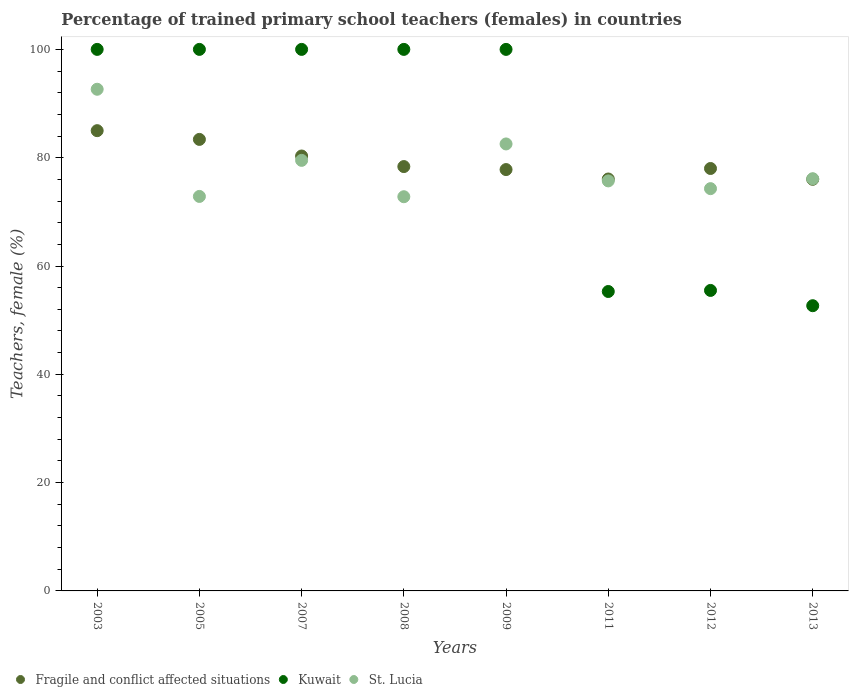What is the percentage of trained primary school teachers (females) in St. Lucia in 2007?
Your answer should be very brief. 79.51. Across all years, what is the maximum percentage of trained primary school teachers (females) in St. Lucia?
Make the answer very short. 92.64. Across all years, what is the minimum percentage of trained primary school teachers (females) in Kuwait?
Provide a succinct answer. 52.67. In which year was the percentage of trained primary school teachers (females) in Kuwait minimum?
Keep it short and to the point. 2013. What is the total percentage of trained primary school teachers (females) in Fragile and conflict affected situations in the graph?
Make the answer very short. 634.93. What is the difference between the percentage of trained primary school teachers (females) in Kuwait in 2007 and that in 2012?
Your answer should be compact. 44.51. What is the difference between the percentage of trained primary school teachers (females) in Kuwait in 2011 and the percentage of trained primary school teachers (females) in Fragile and conflict affected situations in 2009?
Your answer should be compact. -22.51. What is the average percentage of trained primary school teachers (females) in St. Lucia per year?
Offer a very short reply. 78.31. In the year 2005, what is the difference between the percentage of trained primary school teachers (females) in Fragile and conflict affected situations and percentage of trained primary school teachers (females) in Kuwait?
Make the answer very short. -16.62. Is the percentage of trained primary school teachers (females) in St. Lucia in 2003 less than that in 2011?
Ensure brevity in your answer.  No. Is the difference between the percentage of trained primary school teachers (females) in Fragile and conflict affected situations in 2007 and 2012 greater than the difference between the percentage of trained primary school teachers (females) in Kuwait in 2007 and 2012?
Ensure brevity in your answer.  No. What is the difference between the highest and the second highest percentage of trained primary school teachers (females) in St. Lucia?
Your answer should be very brief. 10.1. What is the difference between the highest and the lowest percentage of trained primary school teachers (females) in St. Lucia?
Make the answer very short. 19.84. In how many years, is the percentage of trained primary school teachers (females) in St. Lucia greater than the average percentage of trained primary school teachers (females) in St. Lucia taken over all years?
Your answer should be very brief. 3. Does the percentage of trained primary school teachers (females) in St. Lucia monotonically increase over the years?
Offer a very short reply. No. How many dotlines are there?
Provide a succinct answer. 3. How many years are there in the graph?
Keep it short and to the point. 8. Does the graph contain grids?
Ensure brevity in your answer.  No. How many legend labels are there?
Your answer should be very brief. 3. How are the legend labels stacked?
Your response must be concise. Horizontal. What is the title of the graph?
Provide a short and direct response. Percentage of trained primary school teachers (females) in countries. What is the label or title of the X-axis?
Your answer should be very brief. Years. What is the label or title of the Y-axis?
Your response must be concise. Teachers, female (%). What is the Teachers, female (%) in Fragile and conflict affected situations in 2003?
Give a very brief answer. 84.99. What is the Teachers, female (%) of Kuwait in 2003?
Provide a short and direct response. 100. What is the Teachers, female (%) in St. Lucia in 2003?
Make the answer very short. 92.64. What is the Teachers, female (%) of Fragile and conflict affected situations in 2005?
Offer a very short reply. 83.38. What is the Teachers, female (%) in Kuwait in 2005?
Your answer should be compact. 100. What is the Teachers, female (%) of St. Lucia in 2005?
Provide a succinct answer. 72.85. What is the Teachers, female (%) in Fragile and conflict affected situations in 2007?
Give a very brief answer. 80.31. What is the Teachers, female (%) of Kuwait in 2007?
Keep it short and to the point. 100. What is the Teachers, female (%) in St. Lucia in 2007?
Ensure brevity in your answer.  79.51. What is the Teachers, female (%) of Fragile and conflict affected situations in 2008?
Your response must be concise. 78.36. What is the Teachers, female (%) of St. Lucia in 2008?
Your response must be concise. 72.79. What is the Teachers, female (%) of Fragile and conflict affected situations in 2009?
Keep it short and to the point. 77.81. What is the Teachers, female (%) of St. Lucia in 2009?
Give a very brief answer. 82.54. What is the Teachers, female (%) of Fragile and conflict affected situations in 2011?
Your answer should be compact. 76.07. What is the Teachers, female (%) of Kuwait in 2011?
Give a very brief answer. 55.29. What is the Teachers, female (%) of St. Lucia in 2011?
Your answer should be very brief. 75.71. What is the Teachers, female (%) in Fragile and conflict affected situations in 2012?
Give a very brief answer. 78.01. What is the Teachers, female (%) of Kuwait in 2012?
Make the answer very short. 55.49. What is the Teachers, female (%) of St. Lucia in 2012?
Keep it short and to the point. 74.29. What is the Teachers, female (%) in Fragile and conflict affected situations in 2013?
Your answer should be compact. 76.01. What is the Teachers, female (%) of Kuwait in 2013?
Your answer should be compact. 52.67. What is the Teachers, female (%) of St. Lucia in 2013?
Offer a terse response. 76.12. Across all years, what is the maximum Teachers, female (%) of Fragile and conflict affected situations?
Your answer should be compact. 84.99. Across all years, what is the maximum Teachers, female (%) in Kuwait?
Provide a short and direct response. 100. Across all years, what is the maximum Teachers, female (%) in St. Lucia?
Make the answer very short. 92.64. Across all years, what is the minimum Teachers, female (%) in Fragile and conflict affected situations?
Give a very brief answer. 76.01. Across all years, what is the minimum Teachers, female (%) of Kuwait?
Your response must be concise. 52.67. Across all years, what is the minimum Teachers, female (%) in St. Lucia?
Your answer should be very brief. 72.79. What is the total Teachers, female (%) of Fragile and conflict affected situations in the graph?
Your response must be concise. 634.93. What is the total Teachers, female (%) of Kuwait in the graph?
Your response must be concise. 663.45. What is the total Teachers, female (%) of St. Lucia in the graph?
Ensure brevity in your answer.  626.45. What is the difference between the Teachers, female (%) in Fragile and conflict affected situations in 2003 and that in 2005?
Give a very brief answer. 1.61. What is the difference between the Teachers, female (%) of Kuwait in 2003 and that in 2005?
Offer a terse response. 0. What is the difference between the Teachers, female (%) in St. Lucia in 2003 and that in 2005?
Your response must be concise. 19.79. What is the difference between the Teachers, female (%) in Fragile and conflict affected situations in 2003 and that in 2007?
Your response must be concise. 4.68. What is the difference between the Teachers, female (%) of St. Lucia in 2003 and that in 2007?
Your answer should be very brief. 13.13. What is the difference between the Teachers, female (%) of Fragile and conflict affected situations in 2003 and that in 2008?
Give a very brief answer. 6.63. What is the difference between the Teachers, female (%) of St. Lucia in 2003 and that in 2008?
Provide a short and direct response. 19.84. What is the difference between the Teachers, female (%) of Fragile and conflict affected situations in 2003 and that in 2009?
Give a very brief answer. 7.18. What is the difference between the Teachers, female (%) in Kuwait in 2003 and that in 2009?
Ensure brevity in your answer.  0. What is the difference between the Teachers, female (%) in St. Lucia in 2003 and that in 2009?
Ensure brevity in your answer.  10.1. What is the difference between the Teachers, female (%) of Fragile and conflict affected situations in 2003 and that in 2011?
Ensure brevity in your answer.  8.93. What is the difference between the Teachers, female (%) of Kuwait in 2003 and that in 2011?
Your answer should be compact. 44.71. What is the difference between the Teachers, female (%) in St. Lucia in 2003 and that in 2011?
Offer a very short reply. 16.92. What is the difference between the Teachers, female (%) of Fragile and conflict affected situations in 2003 and that in 2012?
Keep it short and to the point. 6.99. What is the difference between the Teachers, female (%) of Kuwait in 2003 and that in 2012?
Offer a terse response. 44.51. What is the difference between the Teachers, female (%) of St. Lucia in 2003 and that in 2012?
Make the answer very short. 18.35. What is the difference between the Teachers, female (%) in Fragile and conflict affected situations in 2003 and that in 2013?
Your answer should be very brief. 8.98. What is the difference between the Teachers, female (%) in Kuwait in 2003 and that in 2013?
Offer a very short reply. 47.33. What is the difference between the Teachers, female (%) in St. Lucia in 2003 and that in 2013?
Provide a succinct answer. 16.52. What is the difference between the Teachers, female (%) in Fragile and conflict affected situations in 2005 and that in 2007?
Offer a very short reply. 3.07. What is the difference between the Teachers, female (%) in Kuwait in 2005 and that in 2007?
Offer a very short reply. 0. What is the difference between the Teachers, female (%) in St. Lucia in 2005 and that in 2007?
Your response must be concise. -6.66. What is the difference between the Teachers, female (%) in Fragile and conflict affected situations in 2005 and that in 2008?
Ensure brevity in your answer.  5.02. What is the difference between the Teachers, female (%) in Kuwait in 2005 and that in 2008?
Keep it short and to the point. 0. What is the difference between the Teachers, female (%) in St. Lucia in 2005 and that in 2008?
Your response must be concise. 0.05. What is the difference between the Teachers, female (%) of Fragile and conflict affected situations in 2005 and that in 2009?
Ensure brevity in your answer.  5.57. What is the difference between the Teachers, female (%) in Kuwait in 2005 and that in 2009?
Provide a succinct answer. 0. What is the difference between the Teachers, female (%) of St. Lucia in 2005 and that in 2009?
Provide a short and direct response. -9.69. What is the difference between the Teachers, female (%) in Fragile and conflict affected situations in 2005 and that in 2011?
Ensure brevity in your answer.  7.31. What is the difference between the Teachers, female (%) in Kuwait in 2005 and that in 2011?
Your answer should be compact. 44.71. What is the difference between the Teachers, female (%) of St. Lucia in 2005 and that in 2011?
Your answer should be very brief. -2.87. What is the difference between the Teachers, female (%) of Fragile and conflict affected situations in 2005 and that in 2012?
Provide a short and direct response. 5.37. What is the difference between the Teachers, female (%) in Kuwait in 2005 and that in 2012?
Offer a very short reply. 44.51. What is the difference between the Teachers, female (%) in St. Lucia in 2005 and that in 2012?
Ensure brevity in your answer.  -1.44. What is the difference between the Teachers, female (%) of Fragile and conflict affected situations in 2005 and that in 2013?
Offer a terse response. 7.37. What is the difference between the Teachers, female (%) in Kuwait in 2005 and that in 2013?
Make the answer very short. 47.33. What is the difference between the Teachers, female (%) of St. Lucia in 2005 and that in 2013?
Give a very brief answer. -3.27. What is the difference between the Teachers, female (%) in Fragile and conflict affected situations in 2007 and that in 2008?
Offer a terse response. 1.95. What is the difference between the Teachers, female (%) of St. Lucia in 2007 and that in 2008?
Your answer should be very brief. 6.71. What is the difference between the Teachers, female (%) in Fragile and conflict affected situations in 2007 and that in 2009?
Offer a very short reply. 2.5. What is the difference between the Teachers, female (%) in St. Lucia in 2007 and that in 2009?
Your answer should be compact. -3.03. What is the difference between the Teachers, female (%) of Fragile and conflict affected situations in 2007 and that in 2011?
Provide a short and direct response. 4.25. What is the difference between the Teachers, female (%) of Kuwait in 2007 and that in 2011?
Your response must be concise. 44.71. What is the difference between the Teachers, female (%) of St. Lucia in 2007 and that in 2011?
Ensure brevity in your answer.  3.79. What is the difference between the Teachers, female (%) in Fragile and conflict affected situations in 2007 and that in 2012?
Your answer should be compact. 2.31. What is the difference between the Teachers, female (%) of Kuwait in 2007 and that in 2012?
Offer a very short reply. 44.51. What is the difference between the Teachers, female (%) in St. Lucia in 2007 and that in 2012?
Ensure brevity in your answer.  5.22. What is the difference between the Teachers, female (%) in Fragile and conflict affected situations in 2007 and that in 2013?
Provide a short and direct response. 4.3. What is the difference between the Teachers, female (%) in Kuwait in 2007 and that in 2013?
Your answer should be very brief. 47.33. What is the difference between the Teachers, female (%) of St. Lucia in 2007 and that in 2013?
Keep it short and to the point. 3.39. What is the difference between the Teachers, female (%) in Fragile and conflict affected situations in 2008 and that in 2009?
Your answer should be compact. 0.56. What is the difference between the Teachers, female (%) in Kuwait in 2008 and that in 2009?
Keep it short and to the point. 0. What is the difference between the Teachers, female (%) of St. Lucia in 2008 and that in 2009?
Keep it short and to the point. -9.75. What is the difference between the Teachers, female (%) in Fragile and conflict affected situations in 2008 and that in 2011?
Make the answer very short. 2.3. What is the difference between the Teachers, female (%) of Kuwait in 2008 and that in 2011?
Offer a very short reply. 44.71. What is the difference between the Teachers, female (%) in St. Lucia in 2008 and that in 2011?
Your response must be concise. -2.92. What is the difference between the Teachers, female (%) in Fragile and conflict affected situations in 2008 and that in 2012?
Keep it short and to the point. 0.36. What is the difference between the Teachers, female (%) of Kuwait in 2008 and that in 2012?
Offer a terse response. 44.51. What is the difference between the Teachers, female (%) of St. Lucia in 2008 and that in 2012?
Provide a succinct answer. -1.49. What is the difference between the Teachers, female (%) of Fragile and conflict affected situations in 2008 and that in 2013?
Your response must be concise. 2.35. What is the difference between the Teachers, female (%) in Kuwait in 2008 and that in 2013?
Make the answer very short. 47.33. What is the difference between the Teachers, female (%) of St. Lucia in 2008 and that in 2013?
Your response must be concise. -3.33. What is the difference between the Teachers, female (%) of Fragile and conflict affected situations in 2009 and that in 2011?
Make the answer very short. 1.74. What is the difference between the Teachers, female (%) of Kuwait in 2009 and that in 2011?
Offer a terse response. 44.71. What is the difference between the Teachers, female (%) in St. Lucia in 2009 and that in 2011?
Provide a succinct answer. 6.83. What is the difference between the Teachers, female (%) of Fragile and conflict affected situations in 2009 and that in 2012?
Keep it short and to the point. -0.2. What is the difference between the Teachers, female (%) of Kuwait in 2009 and that in 2012?
Offer a very short reply. 44.51. What is the difference between the Teachers, female (%) of St. Lucia in 2009 and that in 2012?
Make the answer very short. 8.25. What is the difference between the Teachers, female (%) of Fragile and conflict affected situations in 2009 and that in 2013?
Your answer should be very brief. 1.8. What is the difference between the Teachers, female (%) of Kuwait in 2009 and that in 2013?
Offer a terse response. 47.33. What is the difference between the Teachers, female (%) of St. Lucia in 2009 and that in 2013?
Give a very brief answer. 6.42. What is the difference between the Teachers, female (%) of Fragile and conflict affected situations in 2011 and that in 2012?
Your answer should be compact. -1.94. What is the difference between the Teachers, female (%) in Kuwait in 2011 and that in 2012?
Offer a terse response. -0.2. What is the difference between the Teachers, female (%) of St. Lucia in 2011 and that in 2012?
Provide a succinct answer. 1.43. What is the difference between the Teachers, female (%) in Fragile and conflict affected situations in 2011 and that in 2013?
Provide a short and direct response. 0.06. What is the difference between the Teachers, female (%) of Kuwait in 2011 and that in 2013?
Provide a succinct answer. 2.62. What is the difference between the Teachers, female (%) of St. Lucia in 2011 and that in 2013?
Your answer should be very brief. -0.41. What is the difference between the Teachers, female (%) of Fragile and conflict affected situations in 2012 and that in 2013?
Give a very brief answer. 2. What is the difference between the Teachers, female (%) of Kuwait in 2012 and that in 2013?
Offer a very short reply. 2.82. What is the difference between the Teachers, female (%) in St. Lucia in 2012 and that in 2013?
Give a very brief answer. -1.83. What is the difference between the Teachers, female (%) in Fragile and conflict affected situations in 2003 and the Teachers, female (%) in Kuwait in 2005?
Ensure brevity in your answer.  -15.01. What is the difference between the Teachers, female (%) in Fragile and conflict affected situations in 2003 and the Teachers, female (%) in St. Lucia in 2005?
Provide a short and direct response. 12.14. What is the difference between the Teachers, female (%) in Kuwait in 2003 and the Teachers, female (%) in St. Lucia in 2005?
Your answer should be compact. 27.15. What is the difference between the Teachers, female (%) of Fragile and conflict affected situations in 2003 and the Teachers, female (%) of Kuwait in 2007?
Offer a terse response. -15.01. What is the difference between the Teachers, female (%) of Fragile and conflict affected situations in 2003 and the Teachers, female (%) of St. Lucia in 2007?
Your response must be concise. 5.48. What is the difference between the Teachers, female (%) of Kuwait in 2003 and the Teachers, female (%) of St. Lucia in 2007?
Ensure brevity in your answer.  20.49. What is the difference between the Teachers, female (%) in Fragile and conflict affected situations in 2003 and the Teachers, female (%) in Kuwait in 2008?
Your response must be concise. -15.01. What is the difference between the Teachers, female (%) of Fragile and conflict affected situations in 2003 and the Teachers, female (%) of St. Lucia in 2008?
Offer a terse response. 12.2. What is the difference between the Teachers, female (%) of Kuwait in 2003 and the Teachers, female (%) of St. Lucia in 2008?
Your answer should be compact. 27.21. What is the difference between the Teachers, female (%) in Fragile and conflict affected situations in 2003 and the Teachers, female (%) in Kuwait in 2009?
Provide a succinct answer. -15.01. What is the difference between the Teachers, female (%) of Fragile and conflict affected situations in 2003 and the Teachers, female (%) of St. Lucia in 2009?
Your answer should be compact. 2.45. What is the difference between the Teachers, female (%) in Kuwait in 2003 and the Teachers, female (%) in St. Lucia in 2009?
Provide a succinct answer. 17.46. What is the difference between the Teachers, female (%) in Fragile and conflict affected situations in 2003 and the Teachers, female (%) in Kuwait in 2011?
Your answer should be compact. 29.7. What is the difference between the Teachers, female (%) in Fragile and conflict affected situations in 2003 and the Teachers, female (%) in St. Lucia in 2011?
Your answer should be very brief. 9.28. What is the difference between the Teachers, female (%) in Kuwait in 2003 and the Teachers, female (%) in St. Lucia in 2011?
Your answer should be compact. 24.29. What is the difference between the Teachers, female (%) of Fragile and conflict affected situations in 2003 and the Teachers, female (%) of Kuwait in 2012?
Offer a terse response. 29.5. What is the difference between the Teachers, female (%) in Fragile and conflict affected situations in 2003 and the Teachers, female (%) in St. Lucia in 2012?
Provide a short and direct response. 10.71. What is the difference between the Teachers, female (%) of Kuwait in 2003 and the Teachers, female (%) of St. Lucia in 2012?
Your answer should be compact. 25.71. What is the difference between the Teachers, female (%) of Fragile and conflict affected situations in 2003 and the Teachers, female (%) of Kuwait in 2013?
Your response must be concise. 32.32. What is the difference between the Teachers, female (%) in Fragile and conflict affected situations in 2003 and the Teachers, female (%) in St. Lucia in 2013?
Provide a succinct answer. 8.87. What is the difference between the Teachers, female (%) of Kuwait in 2003 and the Teachers, female (%) of St. Lucia in 2013?
Give a very brief answer. 23.88. What is the difference between the Teachers, female (%) in Fragile and conflict affected situations in 2005 and the Teachers, female (%) in Kuwait in 2007?
Make the answer very short. -16.62. What is the difference between the Teachers, female (%) of Fragile and conflict affected situations in 2005 and the Teachers, female (%) of St. Lucia in 2007?
Ensure brevity in your answer.  3.87. What is the difference between the Teachers, female (%) in Kuwait in 2005 and the Teachers, female (%) in St. Lucia in 2007?
Keep it short and to the point. 20.49. What is the difference between the Teachers, female (%) of Fragile and conflict affected situations in 2005 and the Teachers, female (%) of Kuwait in 2008?
Provide a succinct answer. -16.62. What is the difference between the Teachers, female (%) in Fragile and conflict affected situations in 2005 and the Teachers, female (%) in St. Lucia in 2008?
Keep it short and to the point. 10.58. What is the difference between the Teachers, female (%) in Kuwait in 2005 and the Teachers, female (%) in St. Lucia in 2008?
Your response must be concise. 27.21. What is the difference between the Teachers, female (%) in Fragile and conflict affected situations in 2005 and the Teachers, female (%) in Kuwait in 2009?
Ensure brevity in your answer.  -16.62. What is the difference between the Teachers, female (%) of Fragile and conflict affected situations in 2005 and the Teachers, female (%) of St. Lucia in 2009?
Ensure brevity in your answer.  0.84. What is the difference between the Teachers, female (%) of Kuwait in 2005 and the Teachers, female (%) of St. Lucia in 2009?
Your response must be concise. 17.46. What is the difference between the Teachers, female (%) in Fragile and conflict affected situations in 2005 and the Teachers, female (%) in Kuwait in 2011?
Offer a terse response. 28.09. What is the difference between the Teachers, female (%) of Fragile and conflict affected situations in 2005 and the Teachers, female (%) of St. Lucia in 2011?
Provide a succinct answer. 7.66. What is the difference between the Teachers, female (%) in Kuwait in 2005 and the Teachers, female (%) in St. Lucia in 2011?
Offer a terse response. 24.29. What is the difference between the Teachers, female (%) in Fragile and conflict affected situations in 2005 and the Teachers, female (%) in Kuwait in 2012?
Your response must be concise. 27.89. What is the difference between the Teachers, female (%) in Fragile and conflict affected situations in 2005 and the Teachers, female (%) in St. Lucia in 2012?
Provide a short and direct response. 9.09. What is the difference between the Teachers, female (%) of Kuwait in 2005 and the Teachers, female (%) of St. Lucia in 2012?
Give a very brief answer. 25.71. What is the difference between the Teachers, female (%) of Fragile and conflict affected situations in 2005 and the Teachers, female (%) of Kuwait in 2013?
Make the answer very short. 30.71. What is the difference between the Teachers, female (%) of Fragile and conflict affected situations in 2005 and the Teachers, female (%) of St. Lucia in 2013?
Your response must be concise. 7.26. What is the difference between the Teachers, female (%) of Kuwait in 2005 and the Teachers, female (%) of St. Lucia in 2013?
Make the answer very short. 23.88. What is the difference between the Teachers, female (%) in Fragile and conflict affected situations in 2007 and the Teachers, female (%) in Kuwait in 2008?
Offer a terse response. -19.69. What is the difference between the Teachers, female (%) in Fragile and conflict affected situations in 2007 and the Teachers, female (%) in St. Lucia in 2008?
Your answer should be very brief. 7.52. What is the difference between the Teachers, female (%) of Kuwait in 2007 and the Teachers, female (%) of St. Lucia in 2008?
Your answer should be compact. 27.21. What is the difference between the Teachers, female (%) of Fragile and conflict affected situations in 2007 and the Teachers, female (%) of Kuwait in 2009?
Provide a short and direct response. -19.69. What is the difference between the Teachers, female (%) of Fragile and conflict affected situations in 2007 and the Teachers, female (%) of St. Lucia in 2009?
Keep it short and to the point. -2.23. What is the difference between the Teachers, female (%) of Kuwait in 2007 and the Teachers, female (%) of St. Lucia in 2009?
Provide a short and direct response. 17.46. What is the difference between the Teachers, female (%) of Fragile and conflict affected situations in 2007 and the Teachers, female (%) of Kuwait in 2011?
Provide a succinct answer. 25.02. What is the difference between the Teachers, female (%) of Fragile and conflict affected situations in 2007 and the Teachers, female (%) of St. Lucia in 2011?
Offer a terse response. 4.6. What is the difference between the Teachers, female (%) of Kuwait in 2007 and the Teachers, female (%) of St. Lucia in 2011?
Provide a short and direct response. 24.29. What is the difference between the Teachers, female (%) of Fragile and conflict affected situations in 2007 and the Teachers, female (%) of Kuwait in 2012?
Offer a very short reply. 24.82. What is the difference between the Teachers, female (%) in Fragile and conflict affected situations in 2007 and the Teachers, female (%) in St. Lucia in 2012?
Provide a short and direct response. 6.03. What is the difference between the Teachers, female (%) in Kuwait in 2007 and the Teachers, female (%) in St. Lucia in 2012?
Provide a succinct answer. 25.71. What is the difference between the Teachers, female (%) of Fragile and conflict affected situations in 2007 and the Teachers, female (%) of Kuwait in 2013?
Give a very brief answer. 27.64. What is the difference between the Teachers, female (%) in Fragile and conflict affected situations in 2007 and the Teachers, female (%) in St. Lucia in 2013?
Your answer should be very brief. 4.19. What is the difference between the Teachers, female (%) in Kuwait in 2007 and the Teachers, female (%) in St. Lucia in 2013?
Ensure brevity in your answer.  23.88. What is the difference between the Teachers, female (%) of Fragile and conflict affected situations in 2008 and the Teachers, female (%) of Kuwait in 2009?
Your response must be concise. -21.64. What is the difference between the Teachers, female (%) in Fragile and conflict affected situations in 2008 and the Teachers, female (%) in St. Lucia in 2009?
Ensure brevity in your answer.  -4.18. What is the difference between the Teachers, female (%) in Kuwait in 2008 and the Teachers, female (%) in St. Lucia in 2009?
Your response must be concise. 17.46. What is the difference between the Teachers, female (%) in Fragile and conflict affected situations in 2008 and the Teachers, female (%) in Kuwait in 2011?
Provide a succinct answer. 23.07. What is the difference between the Teachers, female (%) in Fragile and conflict affected situations in 2008 and the Teachers, female (%) in St. Lucia in 2011?
Give a very brief answer. 2.65. What is the difference between the Teachers, female (%) in Kuwait in 2008 and the Teachers, female (%) in St. Lucia in 2011?
Offer a very short reply. 24.29. What is the difference between the Teachers, female (%) in Fragile and conflict affected situations in 2008 and the Teachers, female (%) in Kuwait in 2012?
Provide a succinct answer. 22.87. What is the difference between the Teachers, female (%) of Fragile and conflict affected situations in 2008 and the Teachers, female (%) of St. Lucia in 2012?
Offer a terse response. 4.08. What is the difference between the Teachers, female (%) in Kuwait in 2008 and the Teachers, female (%) in St. Lucia in 2012?
Your response must be concise. 25.71. What is the difference between the Teachers, female (%) in Fragile and conflict affected situations in 2008 and the Teachers, female (%) in Kuwait in 2013?
Ensure brevity in your answer.  25.69. What is the difference between the Teachers, female (%) of Fragile and conflict affected situations in 2008 and the Teachers, female (%) of St. Lucia in 2013?
Your response must be concise. 2.24. What is the difference between the Teachers, female (%) of Kuwait in 2008 and the Teachers, female (%) of St. Lucia in 2013?
Your answer should be compact. 23.88. What is the difference between the Teachers, female (%) in Fragile and conflict affected situations in 2009 and the Teachers, female (%) in Kuwait in 2011?
Provide a short and direct response. 22.51. What is the difference between the Teachers, female (%) of Fragile and conflict affected situations in 2009 and the Teachers, female (%) of St. Lucia in 2011?
Keep it short and to the point. 2.09. What is the difference between the Teachers, female (%) in Kuwait in 2009 and the Teachers, female (%) in St. Lucia in 2011?
Offer a terse response. 24.29. What is the difference between the Teachers, female (%) in Fragile and conflict affected situations in 2009 and the Teachers, female (%) in Kuwait in 2012?
Provide a short and direct response. 22.32. What is the difference between the Teachers, female (%) in Fragile and conflict affected situations in 2009 and the Teachers, female (%) in St. Lucia in 2012?
Your response must be concise. 3.52. What is the difference between the Teachers, female (%) in Kuwait in 2009 and the Teachers, female (%) in St. Lucia in 2012?
Provide a succinct answer. 25.71. What is the difference between the Teachers, female (%) in Fragile and conflict affected situations in 2009 and the Teachers, female (%) in Kuwait in 2013?
Provide a succinct answer. 25.14. What is the difference between the Teachers, female (%) of Fragile and conflict affected situations in 2009 and the Teachers, female (%) of St. Lucia in 2013?
Offer a terse response. 1.69. What is the difference between the Teachers, female (%) in Kuwait in 2009 and the Teachers, female (%) in St. Lucia in 2013?
Make the answer very short. 23.88. What is the difference between the Teachers, female (%) in Fragile and conflict affected situations in 2011 and the Teachers, female (%) in Kuwait in 2012?
Offer a terse response. 20.58. What is the difference between the Teachers, female (%) in Fragile and conflict affected situations in 2011 and the Teachers, female (%) in St. Lucia in 2012?
Offer a terse response. 1.78. What is the difference between the Teachers, female (%) in Kuwait in 2011 and the Teachers, female (%) in St. Lucia in 2012?
Keep it short and to the point. -18.99. What is the difference between the Teachers, female (%) in Fragile and conflict affected situations in 2011 and the Teachers, female (%) in Kuwait in 2013?
Ensure brevity in your answer.  23.4. What is the difference between the Teachers, female (%) in Fragile and conflict affected situations in 2011 and the Teachers, female (%) in St. Lucia in 2013?
Your answer should be compact. -0.05. What is the difference between the Teachers, female (%) of Kuwait in 2011 and the Teachers, female (%) of St. Lucia in 2013?
Provide a succinct answer. -20.83. What is the difference between the Teachers, female (%) in Fragile and conflict affected situations in 2012 and the Teachers, female (%) in Kuwait in 2013?
Give a very brief answer. 25.34. What is the difference between the Teachers, female (%) of Fragile and conflict affected situations in 2012 and the Teachers, female (%) of St. Lucia in 2013?
Offer a very short reply. 1.89. What is the difference between the Teachers, female (%) of Kuwait in 2012 and the Teachers, female (%) of St. Lucia in 2013?
Offer a terse response. -20.63. What is the average Teachers, female (%) in Fragile and conflict affected situations per year?
Offer a very short reply. 79.37. What is the average Teachers, female (%) of Kuwait per year?
Provide a succinct answer. 82.93. What is the average Teachers, female (%) in St. Lucia per year?
Keep it short and to the point. 78.31. In the year 2003, what is the difference between the Teachers, female (%) in Fragile and conflict affected situations and Teachers, female (%) in Kuwait?
Provide a succinct answer. -15.01. In the year 2003, what is the difference between the Teachers, female (%) in Fragile and conflict affected situations and Teachers, female (%) in St. Lucia?
Make the answer very short. -7.65. In the year 2003, what is the difference between the Teachers, female (%) in Kuwait and Teachers, female (%) in St. Lucia?
Your answer should be compact. 7.36. In the year 2005, what is the difference between the Teachers, female (%) of Fragile and conflict affected situations and Teachers, female (%) of Kuwait?
Provide a succinct answer. -16.62. In the year 2005, what is the difference between the Teachers, female (%) of Fragile and conflict affected situations and Teachers, female (%) of St. Lucia?
Make the answer very short. 10.53. In the year 2005, what is the difference between the Teachers, female (%) in Kuwait and Teachers, female (%) in St. Lucia?
Offer a terse response. 27.15. In the year 2007, what is the difference between the Teachers, female (%) of Fragile and conflict affected situations and Teachers, female (%) of Kuwait?
Provide a short and direct response. -19.69. In the year 2007, what is the difference between the Teachers, female (%) of Fragile and conflict affected situations and Teachers, female (%) of St. Lucia?
Give a very brief answer. 0.8. In the year 2007, what is the difference between the Teachers, female (%) in Kuwait and Teachers, female (%) in St. Lucia?
Provide a short and direct response. 20.49. In the year 2008, what is the difference between the Teachers, female (%) of Fragile and conflict affected situations and Teachers, female (%) of Kuwait?
Keep it short and to the point. -21.64. In the year 2008, what is the difference between the Teachers, female (%) of Fragile and conflict affected situations and Teachers, female (%) of St. Lucia?
Your answer should be very brief. 5.57. In the year 2008, what is the difference between the Teachers, female (%) of Kuwait and Teachers, female (%) of St. Lucia?
Ensure brevity in your answer.  27.21. In the year 2009, what is the difference between the Teachers, female (%) of Fragile and conflict affected situations and Teachers, female (%) of Kuwait?
Offer a very short reply. -22.19. In the year 2009, what is the difference between the Teachers, female (%) of Fragile and conflict affected situations and Teachers, female (%) of St. Lucia?
Offer a terse response. -4.73. In the year 2009, what is the difference between the Teachers, female (%) in Kuwait and Teachers, female (%) in St. Lucia?
Offer a very short reply. 17.46. In the year 2011, what is the difference between the Teachers, female (%) in Fragile and conflict affected situations and Teachers, female (%) in Kuwait?
Give a very brief answer. 20.77. In the year 2011, what is the difference between the Teachers, female (%) in Fragile and conflict affected situations and Teachers, female (%) in St. Lucia?
Ensure brevity in your answer.  0.35. In the year 2011, what is the difference between the Teachers, female (%) of Kuwait and Teachers, female (%) of St. Lucia?
Your answer should be compact. -20.42. In the year 2012, what is the difference between the Teachers, female (%) in Fragile and conflict affected situations and Teachers, female (%) in Kuwait?
Provide a short and direct response. 22.52. In the year 2012, what is the difference between the Teachers, female (%) in Fragile and conflict affected situations and Teachers, female (%) in St. Lucia?
Give a very brief answer. 3.72. In the year 2012, what is the difference between the Teachers, female (%) of Kuwait and Teachers, female (%) of St. Lucia?
Your answer should be compact. -18.8. In the year 2013, what is the difference between the Teachers, female (%) of Fragile and conflict affected situations and Teachers, female (%) of Kuwait?
Your answer should be compact. 23.34. In the year 2013, what is the difference between the Teachers, female (%) in Fragile and conflict affected situations and Teachers, female (%) in St. Lucia?
Keep it short and to the point. -0.11. In the year 2013, what is the difference between the Teachers, female (%) of Kuwait and Teachers, female (%) of St. Lucia?
Provide a succinct answer. -23.45. What is the ratio of the Teachers, female (%) of Fragile and conflict affected situations in 2003 to that in 2005?
Give a very brief answer. 1.02. What is the ratio of the Teachers, female (%) in St. Lucia in 2003 to that in 2005?
Keep it short and to the point. 1.27. What is the ratio of the Teachers, female (%) in Fragile and conflict affected situations in 2003 to that in 2007?
Ensure brevity in your answer.  1.06. What is the ratio of the Teachers, female (%) in St. Lucia in 2003 to that in 2007?
Provide a succinct answer. 1.17. What is the ratio of the Teachers, female (%) in Fragile and conflict affected situations in 2003 to that in 2008?
Give a very brief answer. 1.08. What is the ratio of the Teachers, female (%) in Kuwait in 2003 to that in 2008?
Your answer should be compact. 1. What is the ratio of the Teachers, female (%) of St. Lucia in 2003 to that in 2008?
Provide a short and direct response. 1.27. What is the ratio of the Teachers, female (%) of Fragile and conflict affected situations in 2003 to that in 2009?
Your answer should be very brief. 1.09. What is the ratio of the Teachers, female (%) in St. Lucia in 2003 to that in 2009?
Make the answer very short. 1.12. What is the ratio of the Teachers, female (%) in Fragile and conflict affected situations in 2003 to that in 2011?
Offer a terse response. 1.12. What is the ratio of the Teachers, female (%) in Kuwait in 2003 to that in 2011?
Offer a very short reply. 1.81. What is the ratio of the Teachers, female (%) of St. Lucia in 2003 to that in 2011?
Your answer should be very brief. 1.22. What is the ratio of the Teachers, female (%) in Fragile and conflict affected situations in 2003 to that in 2012?
Offer a terse response. 1.09. What is the ratio of the Teachers, female (%) in Kuwait in 2003 to that in 2012?
Give a very brief answer. 1.8. What is the ratio of the Teachers, female (%) in St. Lucia in 2003 to that in 2012?
Ensure brevity in your answer.  1.25. What is the ratio of the Teachers, female (%) in Fragile and conflict affected situations in 2003 to that in 2013?
Make the answer very short. 1.12. What is the ratio of the Teachers, female (%) in Kuwait in 2003 to that in 2013?
Give a very brief answer. 1.9. What is the ratio of the Teachers, female (%) in St. Lucia in 2003 to that in 2013?
Provide a succinct answer. 1.22. What is the ratio of the Teachers, female (%) of Fragile and conflict affected situations in 2005 to that in 2007?
Ensure brevity in your answer.  1.04. What is the ratio of the Teachers, female (%) in Kuwait in 2005 to that in 2007?
Your response must be concise. 1. What is the ratio of the Teachers, female (%) in St. Lucia in 2005 to that in 2007?
Make the answer very short. 0.92. What is the ratio of the Teachers, female (%) in Fragile and conflict affected situations in 2005 to that in 2008?
Make the answer very short. 1.06. What is the ratio of the Teachers, female (%) in Kuwait in 2005 to that in 2008?
Your response must be concise. 1. What is the ratio of the Teachers, female (%) in St. Lucia in 2005 to that in 2008?
Provide a short and direct response. 1. What is the ratio of the Teachers, female (%) of Fragile and conflict affected situations in 2005 to that in 2009?
Your answer should be compact. 1.07. What is the ratio of the Teachers, female (%) in St. Lucia in 2005 to that in 2009?
Make the answer very short. 0.88. What is the ratio of the Teachers, female (%) of Fragile and conflict affected situations in 2005 to that in 2011?
Your answer should be very brief. 1.1. What is the ratio of the Teachers, female (%) in Kuwait in 2005 to that in 2011?
Make the answer very short. 1.81. What is the ratio of the Teachers, female (%) in St. Lucia in 2005 to that in 2011?
Make the answer very short. 0.96. What is the ratio of the Teachers, female (%) in Fragile and conflict affected situations in 2005 to that in 2012?
Offer a very short reply. 1.07. What is the ratio of the Teachers, female (%) in Kuwait in 2005 to that in 2012?
Keep it short and to the point. 1.8. What is the ratio of the Teachers, female (%) in St. Lucia in 2005 to that in 2012?
Provide a short and direct response. 0.98. What is the ratio of the Teachers, female (%) in Fragile and conflict affected situations in 2005 to that in 2013?
Keep it short and to the point. 1.1. What is the ratio of the Teachers, female (%) in Kuwait in 2005 to that in 2013?
Offer a terse response. 1.9. What is the ratio of the Teachers, female (%) of Fragile and conflict affected situations in 2007 to that in 2008?
Your answer should be very brief. 1.02. What is the ratio of the Teachers, female (%) of St. Lucia in 2007 to that in 2008?
Your response must be concise. 1.09. What is the ratio of the Teachers, female (%) of Fragile and conflict affected situations in 2007 to that in 2009?
Your response must be concise. 1.03. What is the ratio of the Teachers, female (%) of St. Lucia in 2007 to that in 2009?
Offer a terse response. 0.96. What is the ratio of the Teachers, female (%) of Fragile and conflict affected situations in 2007 to that in 2011?
Your response must be concise. 1.06. What is the ratio of the Teachers, female (%) in Kuwait in 2007 to that in 2011?
Your answer should be very brief. 1.81. What is the ratio of the Teachers, female (%) of St. Lucia in 2007 to that in 2011?
Provide a succinct answer. 1.05. What is the ratio of the Teachers, female (%) of Fragile and conflict affected situations in 2007 to that in 2012?
Offer a very short reply. 1.03. What is the ratio of the Teachers, female (%) in Kuwait in 2007 to that in 2012?
Your response must be concise. 1.8. What is the ratio of the Teachers, female (%) in St. Lucia in 2007 to that in 2012?
Provide a short and direct response. 1.07. What is the ratio of the Teachers, female (%) of Fragile and conflict affected situations in 2007 to that in 2013?
Offer a very short reply. 1.06. What is the ratio of the Teachers, female (%) in Kuwait in 2007 to that in 2013?
Provide a succinct answer. 1.9. What is the ratio of the Teachers, female (%) in St. Lucia in 2007 to that in 2013?
Your response must be concise. 1.04. What is the ratio of the Teachers, female (%) of Fragile and conflict affected situations in 2008 to that in 2009?
Give a very brief answer. 1.01. What is the ratio of the Teachers, female (%) in Kuwait in 2008 to that in 2009?
Provide a short and direct response. 1. What is the ratio of the Teachers, female (%) in St. Lucia in 2008 to that in 2009?
Offer a very short reply. 0.88. What is the ratio of the Teachers, female (%) of Fragile and conflict affected situations in 2008 to that in 2011?
Ensure brevity in your answer.  1.03. What is the ratio of the Teachers, female (%) of Kuwait in 2008 to that in 2011?
Give a very brief answer. 1.81. What is the ratio of the Teachers, female (%) in St. Lucia in 2008 to that in 2011?
Provide a succinct answer. 0.96. What is the ratio of the Teachers, female (%) in Fragile and conflict affected situations in 2008 to that in 2012?
Offer a terse response. 1. What is the ratio of the Teachers, female (%) in Kuwait in 2008 to that in 2012?
Keep it short and to the point. 1.8. What is the ratio of the Teachers, female (%) of St. Lucia in 2008 to that in 2012?
Offer a terse response. 0.98. What is the ratio of the Teachers, female (%) of Fragile and conflict affected situations in 2008 to that in 2013?
Make the answer very short. 1.03. What is the ratio of the Teachers, female (%) in Kuwait in 2008 to that in 2013?
Provide a succinct answer. 1.9. What is the ratio of the Teachers, female (%) in St. Lucia in 2008 to that in 2013?
Your response must be concise. 0.96. What is the ratio of the Teachers, female (%) in Fragile and conflict affected situations in 2009 to that in 2011?
Provide a succinct answer. 1.02. What is the ratio of the Teachers, female (%) in Kuwait in 2009 to that in 2011?
Your answer should be compact. 1.81. What is the ratio of the Teachers, female (%) in St. Lucia in 2009 to that in 2011?
Provide a succinct answer. 1.09. What is the ratio of the Teachers, female (%) in Kuwait in 2009 to that in 2012?
Keep it short and to the point. 1.8. What is the ratio of the Teachers, female (%) of St. Lucia in 2009 to that in 2012?
Provide a short and direct response. 1.11. What is the ratio of the Teachers, female (%) in Fragile and conflict affected situations in 2009 to that in 2013?
Offer a very short reply. 1.02. What is the ratio of the Teachers, female (%) in Kuwait in 2009 to that in 2013?
Offer a very short reply. 1.9. What is the ratio of the Teachers, female (%) in St. Lucia in 2009 to that in 2013?
Provide a short and direct response. 1.08. What is the ratio of the Teachers, female (%) of Fragile and conflict affected situations in 2011 to that in 2012?
Offer a terse response. 0.98. What is the ratio of the Teachers, female (%) of St. Lucia in 2011 to that in 2012?
Your answer should be very brief. 1.02. What is the ratio of the Teachers, female (%) in Fragile and conflict affected situations in 2011 to that in 2013?
Offer a very short reply. 1. What is the ratio of the Teachers, female (%) in Kuwait in 2011 to that in 2013?
Make the answer very short. 1.05. What is the ratio of the Teachers, female (%) of Fragile and conflict affected situations in 2012 to that in 2013?
Make the answer very short. 1.03. What is the ratio of the Teachers, female (%) in Kuwait in 2012 to that in 2013?
Your answer should be compact. 1.05. What is the ratio of the Teachers, female (%) of St. Lucia in 2012 to that in 2013?
Your answer should be very brief. 0.98. What is the difference between the highest and the second highest Teachers, female (%) in Fragile and conflict affected situations?
Offer a very short reply. 1.61. What is the difference between the highest and the second highest Teachers, female (%) of Kuwait?
Your answer should be compact. 0. What is the difference between the highest and the second highest Teachers, female (%) in St. Lucia?
Offer a very short reply. 10.1. What is the difference between the highest and the lowest Teachers, female (%) in Fragile and conflict affected situations?
Keep it short and to the point. 8.98. What is the difference between the highest and the lowest Teachers, female (%) in Kuwait?
Provide a succinct answer. 47.33. What is the difference between the highest and the lowest Teachers, female (%) in St. Lucia?
Make the answer very short. 19.84. 